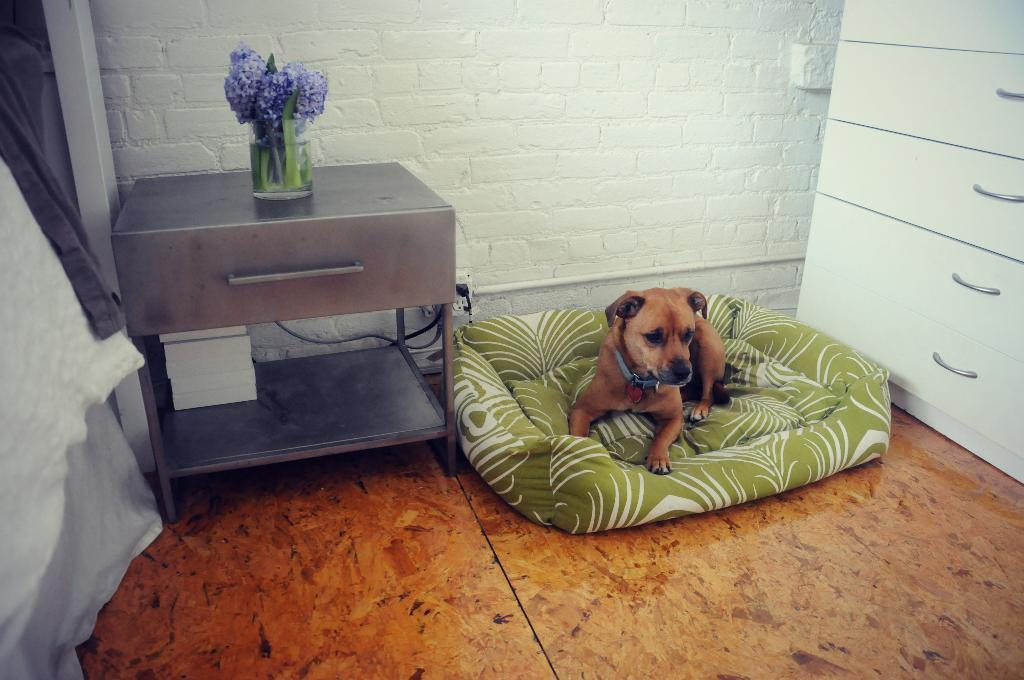What type of animal is on the bed in the image? There is a dog on the bed in the image. What object can be seen on a table in the image? There is a flower vase on a table in the image. What type of thread is being used by the dog in the image? There is no thread present in the image, and the dog is not shown using any thread. What type of curtain can be seen in the image? There is no curtain present in the image; it features a dog on a bed and a flower vase on a table. 